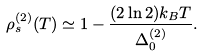Convert formula to latex. <formula><loc_0><loc_0><loc_500><loc_500>\rho _ { s } ^ { ( 2 ) } ( T ) \simeq 1 - \frac { ( 2 \ln 2 ) k _ { B } T } { \Delta _ { 0 } ^ { ( 2 ) } } .</formula> 